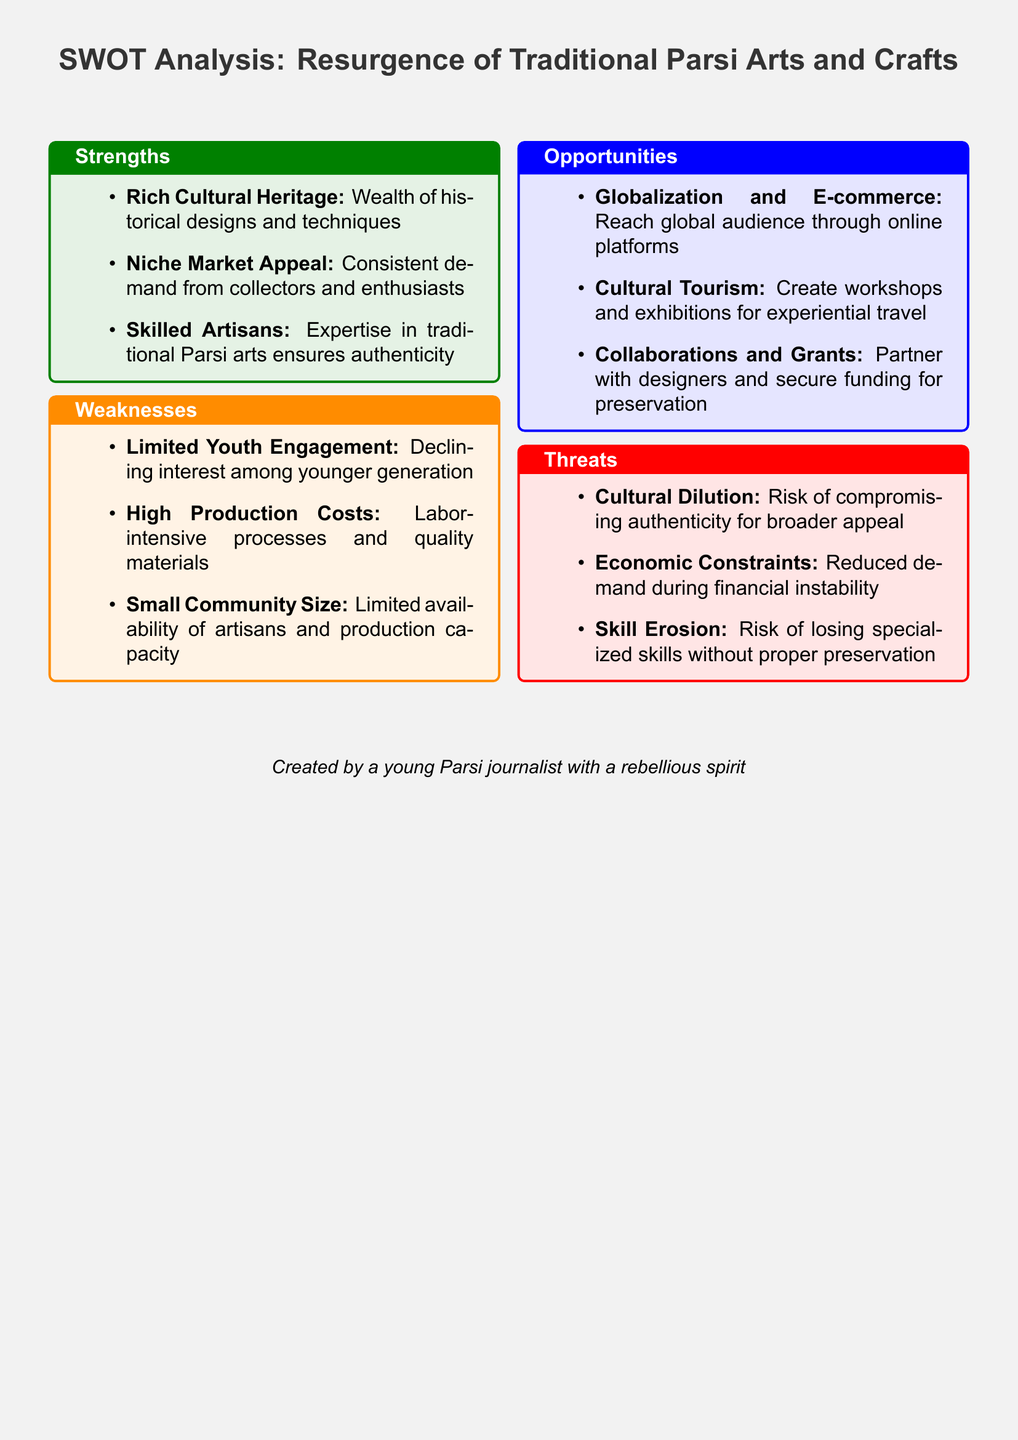What are the strengths identified in the analysis? The strengths section outlines the key advantages of the resurgence of Parsi arts and crafts, which include rich cultural heritage, niche market appeal, and skilled artisans.
Answer: Rich Cultural Heritage, Niche Market Appeal, Skilled Artisans What is one major weakness mentioned? The weaknesses section highlights challenges that could hinder the resurgence of Parsi arts, such as limited youth engagement or high production costs.
Answer: Limited Youth Engagement How many opportunities for Parsi arts and crafts are listed? The opportunities section contains three distinct potential avenues for growth and development in this field.
Answer: Three What is a threat related to cultural practices mentioned? The threats section identifies risks that could arise, specifically mentioning cultural dilution as a significant concern.
Answer: Cultural Dilution What is the title of the document? The title summarizes the content and purpose of the document, focusing on a SWOT analysis of traditional Parsi arts and crafts.
Answer: SWOT Analysis: Resurgence of Traditional Parsi Arts and Crafts How can globalization benefit traditional Parsi arts? The opportunities section mentions how globalization can enhance access to a broader audience through emerging online platforms.
Answer: Reach global audience through online platforms What skill-related risk is indicated in the threats? The threats section highlights the potential for skill erosion, pointing to the fragility of specialized artisan skills amidst changing times.
Answer: Skill Erosion What is one suggested opportunity for cultural tourism? The opportunities section recommends creating workshops and exhibitions as a means of engaging tourists in experiential learning.
Answer: Create workshops and exhibitions for experiential travel 